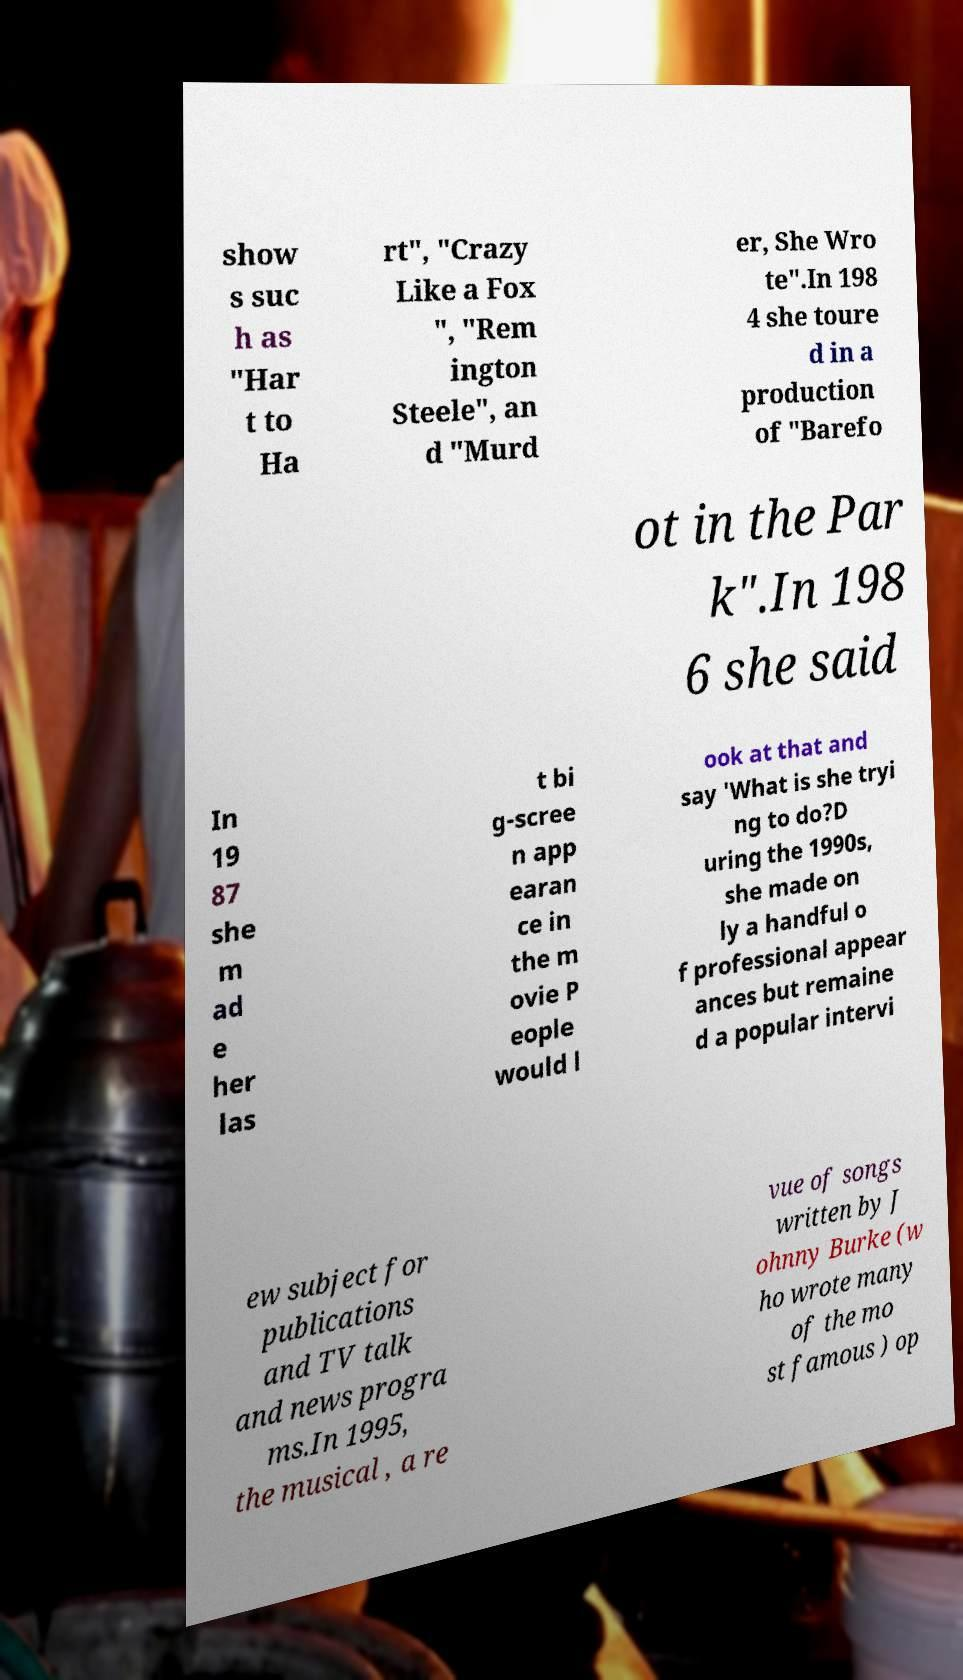Could you extract and type out the text from this image? show s suc h as "Har t to Ha rt", "Crazy Like a Fox ", "Rem ington Steele", an d "Murd er, She Wro te".In 198 4 she toure d in a production of "Barefo ot in the Par k".In 198 6 she said In 19 87 she m ad e her las t bi g-scree n app earan ce in the m ovie P eople would l ook at that and say 'What is she tryi ng to do?D uring the 1990s, she made on ly a handful o f professional appear ances but remaine d a popular intervi ew subject for publications and TV talk and news progra ms.In 1995, the musical , a re vue of songs written by J ohnny Burke (w ho wrote many of the mo st famous ) op 